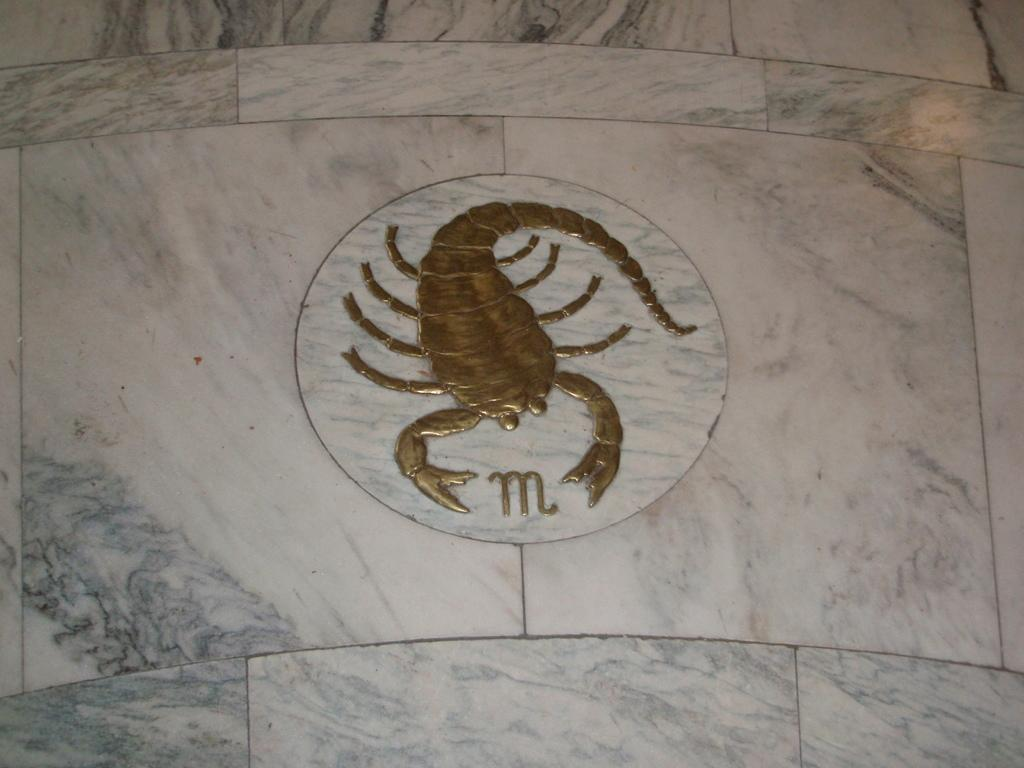What is the main subject of the image? The main subject of the image is a picture of a scorpion. Where is the picture located in the image? The picture is on the wall. Can you see a group of frogs forming a circle around the scorpion picture in the image? There is no group of frogs or any circle present in the image; it only features a picture of a scorpion on the wall. 